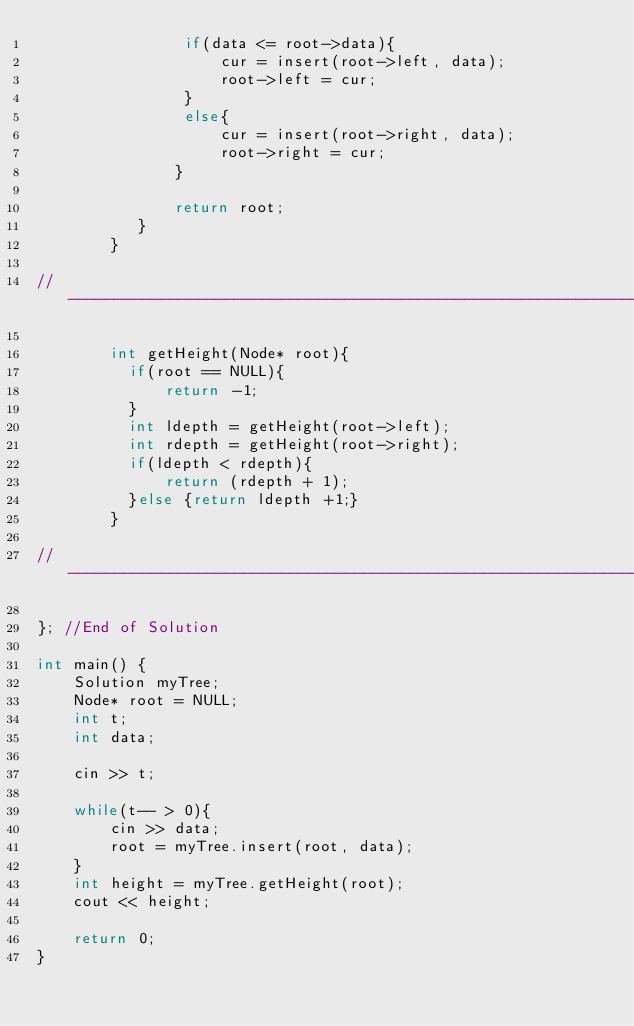<code> <loc_0><loc_0><loc_500><loc_500><_C++_>                if(data <= root->data){
                    cur = insert(root->left, data);
                    root->left = cur;
                }
                else{
                    cur = insert(root->right, data);
                    root->right = cur;
               }

               return root;
           }
        }
        
//---------------------------------------------------------------------

		int getHeight(Node* root){
          if(root == NULL){
              return -1;
          }
          int ldepth = getHeight(root->left);
          int rdepth = getHeight(root->right);
          if(ldepth < rdepth){
              return (rdepth + 1);
          }else {return ldepth +1;}
        }

//-----------------------------------------------------------------

}; //End of Solution

int main() {
    Solution myTree;
    Node* root = NULL;
    int t;
    int data;

    cin >> t;

    while(t-- > 0){
        cin >> data;
        root = myTree.insert(root, data);
    }
    int height = myTree.getHeight(root);
    cout << height;

    return 0;
}
    
       
            
        
</code> 